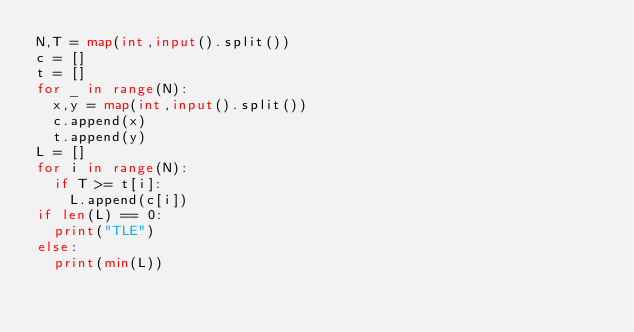Convert code to text. <code><loc_0><loc_0><loc_500><loc_500><_Python_>N,T = map(int,input().split())
c = []
t = []
for _ in range(N):
  x,y = map(int,input().split())
  c.append(x)
  t.append(y)
L = []  
for i in range(N):
  if T >= t[i]:
    L.append(c[i])
if len(L) == 0:
  print("TLE")
else:    
  print(min(L))  </code> 